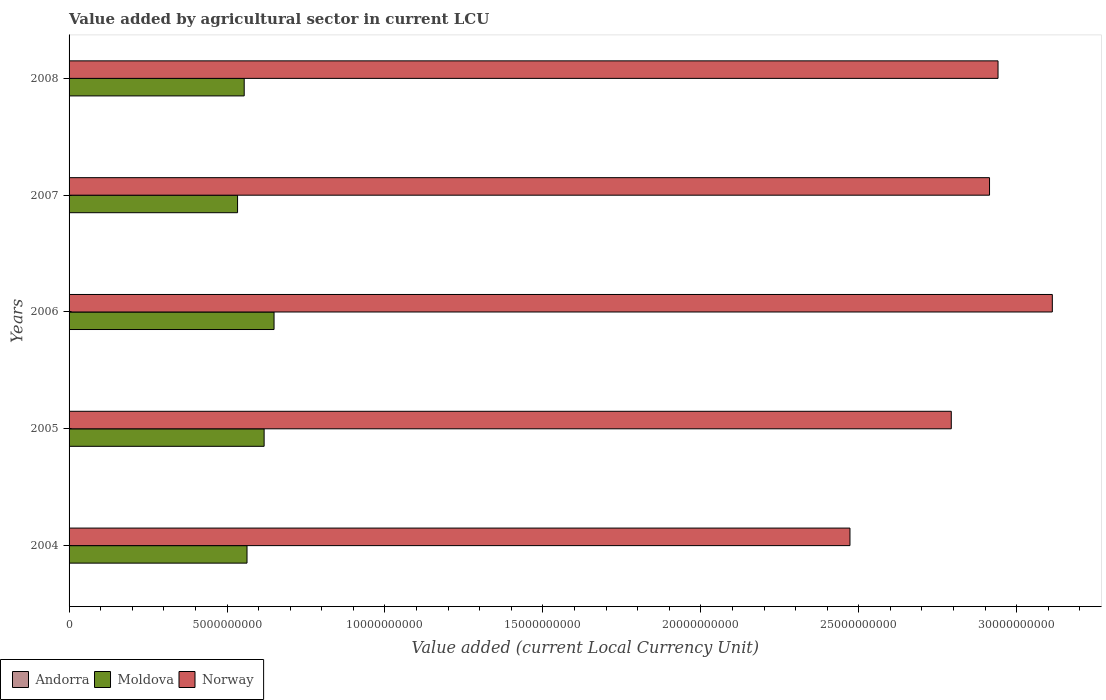Are the number of bars per tick equal to the number of legend labels?
Your response must be concise. Yes. Are the number of bars on each tick of the Y-axis equal?
Keep it short and to the point. Yes. How many bars are there on the 2nd tick from the top?
Provide a succinct answer. 3. In how many cases, is the number of bars for a given year not equal to the number of legend labels?
Ensure brevity in your answer.  0. What is the value added by agricultural sector in Moldova in 2004?
Your answer should be compact. 5.63e+09. Across all years, what is the maximum value added by agricultural sector in Andorra?
Your answer should be very brief. 1.13e+07. Across all years, what is the minimum value added by agricultural sector in Moldova?
Make the answer very short. 5.33e+09. In which year was the value added by agricultural sector in Moldova maximum?
Your response must be concise. 2006. In which year was the value added by agricultural sector in Norway minimum?
Ensure brevity in your answer.  2004. What is the total value added by agricultural sector in Norway in the graph?
Your response must be concise. 1.42e+11. What is the difference between the value added by agricultural sector in Andorra in 2004 and that in 2008?
Your answer should be compact. -1.37e+06. What is the difference between the value added by agricultural sector in Andorra in 2004 and the value added by agricultural sector in Norway in 2005?
Your answer should be very brief. -2.79e+1. What is the average value added by agricultural sector in Andorra per year?
Provide a short and direct response. 1.05e+07. In the year 2007, what is the difference between the value added by agricultural sector in Norway and value added by agricultural sector in Moldova?
Keep it short and to the point. 2.38e+1. In how many years, is the value added by agricultural sector in Moldova greater than 12000000000 LCU?
Provide a succinct answer. 0. What is the ratio of the value added by agricultural sector in Andorra in 2005 to that in 2006?
Make the answer very short. 0.99. What is the difference between the highest and the second highest value added by agricultural sector in Moldova?
Your answer should be very brief. 3.14e+08. What is the difference between the highest and the lowest value added by agricultural sector in Andorra?
Your answer should be very brief. 1.37e+06. In how many years, is the value added by agricultural sector in Norway greater than the average value added by agricultural sector in Norway taken over all years?
Offer a terse response. 3. Is the sum of the value added by agricultural sector in Andorra in 2004 and 2006 greater than the maximum value added by agricultural sector in Moldova across all years?
Your answer should be very brief. No. What does the 3rd bar from the bottom in 2004 represents?
Your answer should be very brief. Norway. Is it the case that in every year, the sum of the value added by agricultural sector in Norway and value added by agricultural sector in Andorra is greater than the value added by agricultural sector in Moldova?
Offer a terse response. Yes. How many bars are there?
Give a very brief answer. 15. How many years are there in the graph?
Your response must be concise. 5. Are the values on the major ticks of X-axis written in scientific E-notation?
Offer a very short reply. No. Does the graph contain any zero values?
Make the answer very short. No. Does the graph contain grids?
Ensure brevity in your answer.  No. How many legend labels are there?
Your answer should be very brief. 3. How are the legend labels stacked?
Ensure brevity in your answer.  Horizontal. What is the title of the graph?
Provide a succinct answer. Value added by agricultural sector in current LCU. Does "Venezuela" appear as one of the legend labels in the graph?
Keep it short and to the point. No. What is the label or title of the X-axis?
Make the answer very short. Value added (current Local Currency Unit). What is the label or title of the Y-axis?
Offer a terse response. Years. What is the Value added (current Local Currency Unit) of Andorra in 2004?
Your answer should be very brief. 9.95e+06. What is the Value added (current Local Currency Unit) of Moldova in 2004?
Your answer should be compact. 5.63e+09. What is the Value added (current Local Currency Unit) of Norway in 2004?
Your answer should be compact. 2.47e+1. What is the Value added (current Local Currency Unit) of Andorra in 2005?
Keep it short and to the point. 1.00e+07. What is the Value added (current Local Currency Unit) of Moldova in 2005?
Ensure brevity in your answer.  6.17e+09. What is the Value added (current Local Currency Unit) in Norway in 2005?
Your answer should be compact. 2.79e+1. What is the Value added (current Local Currency Unit) in Andorra in 2006?
Offer a very short reply. 1.01e+07. What is the Value added (current Local Currency Unit) of Moldova in 2006?
Ensure brevity in your answer.  6.49e+09. What is the Value added (current Local Currency Unit) in Norway in 2006?
Keep it short and to the point. 3.11e+1. What is the Value added (current Local Currency Unit) of Andorra in 2007?
Your response must be concise. 1.10e+07. What is the Value added (current Local Currency Unit) in Moldova in 2007?
Ensure brevity in your answer.  5.33e+09. What is the Value added (current Local Currency Unit) of Norway in 2007?
Your answer should be compact. 2.91e+1. What is the Value added (current Local Currency Unit) in Andorra in 2008?
Provide a succinct answer. 1.13e+07. What is the Value added (current Local Currency Unit) in Moldova in 2008?
Make the answer very short. 5.54e+09. What is the Value added (current Local Currency Unit) of Norway in 2008?
Keep it short and to the point. 2.94e+1. Across all years, what is the maximum Value added (current Local Currency Unit) in Andorra?
Ensure brevity in your answer.  1.13e+07. Across all years, what is the maximum Value added (current Local Currency Unit) in Moldova?
Provide a succinct answer. 6.49e+09. Across all years, what is the maximum Value added (current Local Currency Unit) in Norway?
Your response must be concise. 3.11e+1. Across all years, what is the minimum Value added (current Local Currency Unit) in Andorra?
Ensure brevity in your answer.  9.95e+06. Across all years, what is the minimum Value added (current Local Currency Unit) of Moldova?
Offer a terse response. 5.33e+09. Across all years, what is the minimum Value added (current Local Currency Unit) in Norway?
Your response must be concise. 2.47e+1. What is the total Value added (current Local Currency Unit) of Andorra in the graph?
Offer a terse response. 5.24e+07. What is the total Value added (current Local Currency Unit) of Moldova in the graph?
Ensure brevity in your answer.  2.92e+1. What is the total Value added (current Local Currency Unit) of Norway in the graph?
Provide a short and direct response. 1.42e+11. What is the difference between the Value added (current Local Currency Unit) in Andorra in 2004 and that in 2005?
Offer a terse response. -6.00e+04. What is the difference between the Value added (current Local Currency Unit) in Moldova in 2004 and that in 2005?
Your response must be concise. -5.41e+08. What is the difference between the Value added (current Local Currency Unit) in Norway in 2004 and that in 2005?
Provide a succinct answer. -3.21e+09. What is the difference between the Value added (current Local Currency Unit) of Andorra in 2004 and that in 2006?
Make the answer very short. -1.90e+05. What is the difference between the Value added (current Local Currency Unit) of Moldova in 2004 and that in 2006?
Keep it short and to the point. -8.55e+08. What is the difference between the Value added (current Local Currency Unit) of Norway in 2004 and that in 2006?
Keep it short and to the point. -6.41e+09. What is the difference between the Value added (current Local Currency Unit) in Andorra in 2004 and that in 2007?
Your response must be concise. -1.06e+06. What is the difference between the Value added (current Local Currency Unit) in Moldova in 2004 and that in 2007?
Provide a succinct answer. 2.99e+08. What is the difference between the Value added (current Local Currency Unit) of Norway in 2004 and that in 2007?
Your answer should be very brief. -4.42e+09. What is the difference between the Value added (current Local Currency Unit) of Andorra in 2004 and that in 2008?
Ensure brevity in your answer.  -1.37e+06. What is the difference between the Value added (current Local Currency Unit) of Moldova in 2004 and that in 2008?
Provide a short and direct response. 8.94e+07. What is the difference between the Value added (current Local Currency Unit) of Norway in 2004 and that in 2008?
Give a very brief answer. -4.69e+09. What is the difference between the Value added (current Local Currency Unit) of Moldova in 2005 and that in 2006?
Offer a very short reply. -3.14e+08. What is the difference between the Value added (current Local Currency Unit) in Norway in 2005 and that in 2006?
Your response must be concise. -3.20e+09. What is the difference between the Value added (current Local Currency Unit) in Andorra in 2005 and that in 2007?
Give a very brief answer. -1.00e+06. What is the difference between the Value added (current Local Currency Unit) of Moldova in 2005 and that in 2007?
Your answer should be very brief. 8.41e+08. What is the difference between the Value added (current Local Currency Unit) in Norway in 2005 and that in 2007?
Provide a succinct answer. -1.21e+09. What is the difference between the Value added (current Local Currency Unit) in Andorra in 2005 and that in 2008?
Provide a short and direct response. -1.31e+06. What is the difference between the Value added (current Local Currency Unit) in Moldova in 2005 and that in 2008?
Provide a succinct answer. 6.31e+08. What is the difference between the Value added (current Local Currency Unit) of Norway in 2005 and that in 2008?
Provide a short and direct response. -1.48e+09. What is the difference between the Value added (current Local Currency Unit) of Andorra in 2006 and that in 2007?
Your answer should be compact. -8.70e+05. What is the difference between the Value added (current Local Currency Unit) in Moldova in 2006 and that in 2007?
Keep it short and to the point. 1.15e+09. What is the difference between the Value added (current Local Currency Unit) of Norway in 2006 and that in 2007?
Your answer should be very brief. 1.99e+09. What is the difference between the Value added (current Local Currency Unit) of Andorra in 2006 and that in 2008?
Provide a succinct answer. -1.18e+06. What is the difference between the Value added (current Local Currency Unit) in Moldova in 2006 and that in 2008?
Your response must be concise. 9.45e+08. What is the difference between the Value added (current Local Currency Unit) of Norway in 2006 and that in 2008?
Make the answer very short. 1.72e+09. What is the difference between the Value added (current Local Currency Unit) of Andorra in 2007 and that in 2008?
Provide a succinct answer. -3.10e+05. What is the difference between the Value added (current Local Currency Unit) in Moldova in 2007 and that in 2008?
Your response must be concise. -2.10e+08. What is the difference between the Value added (current Local Currency Unit) of Norway in 2007 and that in 2008?
Give a very brief answer. -2.69e+08. What is the difference between the Value added (current Local Currency Unit) in Andorra in 2004 and the Value added (current Local Currency Unit) in Moldova in 2005?
Your answer should be very brief. -6.16e+09. What is the difference between the Value added (current Local Currency Unit) in Andorra in 2004 and the Value added (current Local Currency Unit) in Norway in 2005?
Your answer should be very brief. -2.79e+1. What is the difference between the Value added (current Local Currency Unit) of Moldova in 2004 and the Value added (current Local Currency Unit) of Norway in 2005?
Ensure brevity in your answer.  -2.23e+1. What is the difference between the Value added (current Local Currency Unit) of Andorra in 2004 and the Value added (current Local Currency Unit) of Moldova in 2006?
Provide a short and direct response. -6.48e+09. What is the difference between the Value added (current Local Currency Unit) of Andorra in 2004 and the Value added (current Local Currency Unit) of Norway in 2006?
Offer a very short reply. -3.11e+1. What is the difference between the Value added (current Local Currency Unit) in Moldova in 2004 and the Value added (current Local Currency Unit) in Norway in 2006?
Make the answer very short. -2.55e+1. What is the difference between the Value added (current Local Currency Unit) in Andorra in 2004 and the Value added (current Local Currency Unit) in Moldova in 2007?
Offer a terse response. -5.32e+09. What is the difference between the Value added (current Local Currency Unit) in Andorra in 2004 and the Value added (current Local Currency Unit) in Norway in 2007?
Give a very brief answer. -2.91e+1. What is the difference between the Value added (current Local Currency Unit) of Moldova in 2004 and the Value added (current Local Currency Unit) of Norway in 2007?
Offer a terse response. -2.35e+1. What is the difference between the Value added (current Local Currency Unit) in Andorra in 2004 and the Value added (current Local Currency Unit) in Moldova in 2008?
Keep it short and to the point. -5.53e+09. What is the difference between the Value added (current Local Currency Unit) of Andorra in 2004 and the Value added (current Local Currency Unit) of Norway in 2008?
Offer a terse response. -2.94e+1. What is the difference between the Value added (current Local Currency Unit) in Moldova in 2004 and the Value added (current Local Currency Unit) in Norway in 2008?
Give a very brief answer. -2.38e+1. What is the difference between the Value added (current Local Currency Unit) of Andorra in 2005 and the Value added (current Local Currency Unit) of Moldova in 2006?
Make the answer very short. -6.48e+09. What is the difference between the Value added (current Local Currency Unit) in Andorra in 2005 and the Value added (current Local Currency Unit) in Norway in 2006?
Give a very brief answer. -3.11e+1. What is the difference between the Value added (current Local Currency Unit) of Moldova in 2005 and the Value added (current Local Currency Unit) of Norway in 2006?
Give a very brief answer. -2.50e+1. What is the difference between the Value added (current Local Currency Unit) of Andorra in 2005 and the Value added (current Local Currency Unit) of Moldova in 2007?
Your answer should be very brief. -5.32e+09. What is the difference between the Value added (current Local Currency Unit) of Andorra in 2005 and the Value added (current Local Currency Unit) of Norway in 2007?
Your answer should be compact. -2.91e+1. What is the difference between the Value added (current Local Currency Unit) of Moldova in 2005 and the Value added (current Local Currency Unit) of Norway in 2007?
Ensure brevity in your answer.  -2.30e+1. What is the difference between the Value added (current Local Currency Unit) of Andorra in 2005 and the Value added (current Local Currency Unit) of Moldova in 2008?
Offer a terse response. -5.53e+09. What is the difference between the Value added (current Local Currency Unit) in Andorra in 2005 and the Value added (current Local Currency Unit) in Norway in 2008?
Keep it short and to the point. -2.94e+1. What is the difference between the Value added (current Local Currency Unit) of Moldova in 2005 and the Value added (current Local Currency Unit) of Norway in 2008?
Provide a short and direct response. -2.32e+1. What is the difference between the Value added (current Local Currency Unit) of Andorra in 2006 and the Value added (current Local Currency Unit) of Moldova in 2007?
Give a very brief answer. -5.32e+09. What is the difference between the Value added (current Local Currency Unit) in Andorra in 2006 and the Value added (current Local Currency Unit) in Norway in 2007?
Your response must be concise. -2.91e+1. What is the difference between the Value added (current Local Currency Unit) of Moldova in 2006 and the Value added (current Local Currency Unit) of Norway in 2007?
Your response must be concise. -2.27e+1. What is the difference between the Value added (current Local Currency Unit) of Andorra in 2006 and the Value added (current Local Currency Unit) of Moldova in 2008?
Offer a terse response. -5.53e+09. What is the difference between the Value added (current Local Currency Unit) in Andorra in 2006 and the Value added (current Local Currency Unit) in Norway in 2008?
Ensure brevity in your answer.  -2.94e+1. What is the difference between the Value added (current Local Currency Unit) of Moldova in 2006 and the Value added (current Local Currency Unit) of Norway in 2008?
Offer a terse response. -2.29e+1. What is the difference between the Value added (current Local Currency Unit) of Andorra in 2007 and the Value added (current Local Currency Unit) of Moldova in 2008?
Keep it short and to the point. -5.53e+09. What is the difference between the Value added (current Local Currency Unit) of Andorra in 2007 and the Value added (current Local Currency Unit) of Norway in 2008?
Offer a terse response. -2.94e+1. What is the difference between the Value added (current Local Currency Unit) of Moldova in 2007 and the Value added (current Local Currency Unit) of Norway in 2008?
Offer a very short reply. -2.41e+1. What is the average Value added (current Local Currency Unit) of Andorra per year?
Offer a terse response. 1.05e+07. What is the average Value added (current Local Currency Unit) in Moldova per year?
Offer a very short reply. 5.83e+09. What is the average Value added (current Local Currency Unit) of Norway per year?
Offer a very short reply. 2.85e+1. In the year 2004, what is the difference between the Value added (current Local Currency Unit) in Andorra and Value added (current Local Currency Unit) in Moldova?
Ensure brevity in your answer.  -5.62e+09. In the year 2004, what is the difference between the Value added (current Local Currency Unit) in Andorra and Value added (current Local Currency Unit) in Norway?
Your answer should be very brief. -2.47e+1. In the year 2004, what is the difference between the Value added (current Local Currency Unit) in Moldova and Value added (current Local Currency Unit) in Norway?
Provide a short and direct response. -1.91e+1. In the year 2005, what is the difference between the Value added (current Local Currency Unit) of Andorra and Value added (current Local Currency Unit) of Moldova?
Your response must be concise. -6.16e+09. In the year 2005, what is the difference between the Value added (current Local Currency Unit) of Andorra and Value added (current Local Currency Unit) of Norway?
Your response must be concise. -2.79e+1. In the year 2005, what is the difference between the Value added (current Local Currency Unit) in Moldova and Value added (current Local Currency Unit) in Norway?
Give a very brief answer. -2.18e+1. In the year 2006, what is the difference between the Value added (current Local Currency Unit) in Andorra and Value added (current Local Currency Unit) in Moldova?
Make the answer very short. -6.48e+09. In the year 2006, what is the difference between the Value added (current Local Currency Unit) in Andorra and Value added (current Local Currency Unit) in Norway?
Your answer should be very brief. -3.11e+1. In the year 2006, what is the difference between the Value added (current Local Currency Unit) in Moldova and Value added (current Local Currency Unit) in Norway?
Offer a terse response. -2.46e+1. In the year 2007, what is the difference between the Value added (current Local Currency Unit) of Andorra and Value added (current Local Currency Unit) of Moldova?
Give a very brief answer. -5.32e+09. In the year 2007, what is the difference between the Value added (current Local Currency Unit) in Andorra and Value added (current Local Currency Unit) in Norway?
Your answer should be very brief. -2.91e+1. In the year 2007, what is the difference between the Value added (current Local Currency Unit) of Moldova and Value added (current Local Currency Unit) of Norway?
Offer a terse response. -2.38e+1. In the year 2008, what is the difference between the Value added (current Local Currency Unit) in Andorra and Value added (current Local Currency Unit) in Moldova?
Make the answer very short. -5.53e+09. In the year 2008, what is the difference between the Value added (current Local Currency Unit) in Andorra and Value added (current Local Currency Unit) in Norway?
Give a very brief answer. -2.94e+1. In the year 2008, what is the difference between the Value added (current Local Currency Unit) of Moldova and Value added (current Local Currency Unit) of Norway?
Provide a succinct answer. -2.39e+1. What is the ratio of the Value added (current Local Currency Unit) of Moldova in 2004 to that in 2005?
Make the answer very short. 0.91. What is the ratio of the Value added (current Local Currency Unit) of Norway in 2004 to that in 2005?
Keep it short and to the point. 0.89. What is the ratio of the Value added (current Local Currency Unit) of Andorra in 2004 to that in 2006?
Offer a very short reply. 0.98. What is the ratio of the Value added (current Local Currency Unit) of Moldova in 2004 to that in 2006?
Offer a very short reply. 0.87. What is the ratio of the Value added (current Local Currency Unit) of Norway in 2004 to that in 2006?
Offer a very short reply. 0.79. What is the ratio of the Value added (current Local Currency Unit) of Andorra in 2004 to that in 2007?
Give a very brief answer. 0.9. What is the ratio of the Value added (current Local Currency Unit) of Moldova in 2004 to that in 2007?
Keep it short and to the point. 1.06. What is the ratio of the Value added (current Local Currency Unit) of Norway in 2004 to that in 2007?
Ensure brevity in your answer.  0.85. What is the ratio of the Value added (current Local Currency Unit) in Andorra in 2004 to that in 2008?
Ensure brevity in your answer.  0.88. What is the ratio of the Value added (current Local Currency Unit) of Moldova in 2004 to that in 2008?
Ensure brevity in your answer.  1.02. What is the ratio of the Value added (current Local Currency Unit) in Norway in 2004 to that in 2008?
Ensure brevity in your answer.  0.84. What is the ratio of the Value added (current Local Currency Unit) in Andorra in 2005 to that in 2006?
Give a very brief answer. 0.99. What is the ratio of the Value added (current Local Currency Unit) in Moldova in 2005 to that in 2006?
Offer a terse response. 0.95. What is the ratio of the Value added (current Local Currency Unit) in Norway in 2005 to that in 2006?
Make the answer very short. 0.9. What is the ratio of the Value added (current Local Currency Unit) in Andorra in 2005 to that in 2007?
Offer a terse response. 0.91. What is the ratio of the Value added (current Local Currency Unit) of Moldova in 2005 to that in 2007?
Give a very brief answer. 1.16. What is the ratio of the Value added (current Local Currency Unit) in Norway in 2005 to that in 2007?
Give a very brief answer. 0.96. What is the ratio of the Value added (current Local Currency Unit) of Andorra in 2005 to that in 2008?
Make the answer very short. 0.88. What is the ratio of the Value added (current Local Currency Unit) in Moldova in 2005 to that in 2008?
Provide a short and direct response. 1.11. What is the ratio of the Value added (current Local Currency Unit) of Norway in 2005 to that in 2008?
Offer a terse response. 0.95. What is the ratio of the Value added (current Local Currency Unit) in Andorra in 2006 to that in 2007?
Offer a very short reply. 0.92. What is the ratio of the Value added (current Local Currency Unit) of Moldova in 2006 to that in 2007?
Give a very brief answer. 1.22. What is the ratio of the Value added (current Local Currency Unit) of Norway in 2006 to that in 2007?
Your response must be concise. 1.07. What is the ratio of the Value added (current Local Currency Unit) of Andorra in 2006 to that in 2008?
Keep it short and to the point. 0.9. What is the ratio of the Value added (current Local Currency Unit) in Moldova in 2006 to that in 2008?
Your answer should be compact. 1.17. What is the ratio of the Value added (current Local Currency Unit) in Norway in 2006 to that in 2008?
Make the answer very short. 1.06. What is the ratio of the Value added (current Local Currency Unit) of Andorra in 2007 to that in 2008?
Your answer should be very brief. 0.97. What is the ratio of the Value added (current Local Currency Unit) of Moldova in 2007 to that in 2008?
Your answer should be very brief. 0.96. What is the ratio of the Value added (current Local Currency Unit) of Norway in 2007 to that in 2008?
Your answer should be very brief. 0.99. What is the difference between the highest and the second highest Value added (current Local Currency Unit) in Moldova?
Provide a short and direct response. 3.14e+08. What is the difference between the highest and the second highest Value added (current Local Currency Unit) of Norway?
Your answer should be very brief. 1.72e+09. What is the difference between the highest and the lowest Value added (current Local Currency Unit) of Andorra?
Offer a very short reply. 1.37e+06. What is the difference between the highest and the lowest Value added (current Local Currency Unit) of Moldova?
Provide a succinct answer. 1.15e+09. What is the difference between the highest and the lowest Value added (current Local Currency Unit) of Norway?
Ensure brevity in your answer.  6.41e+09. 